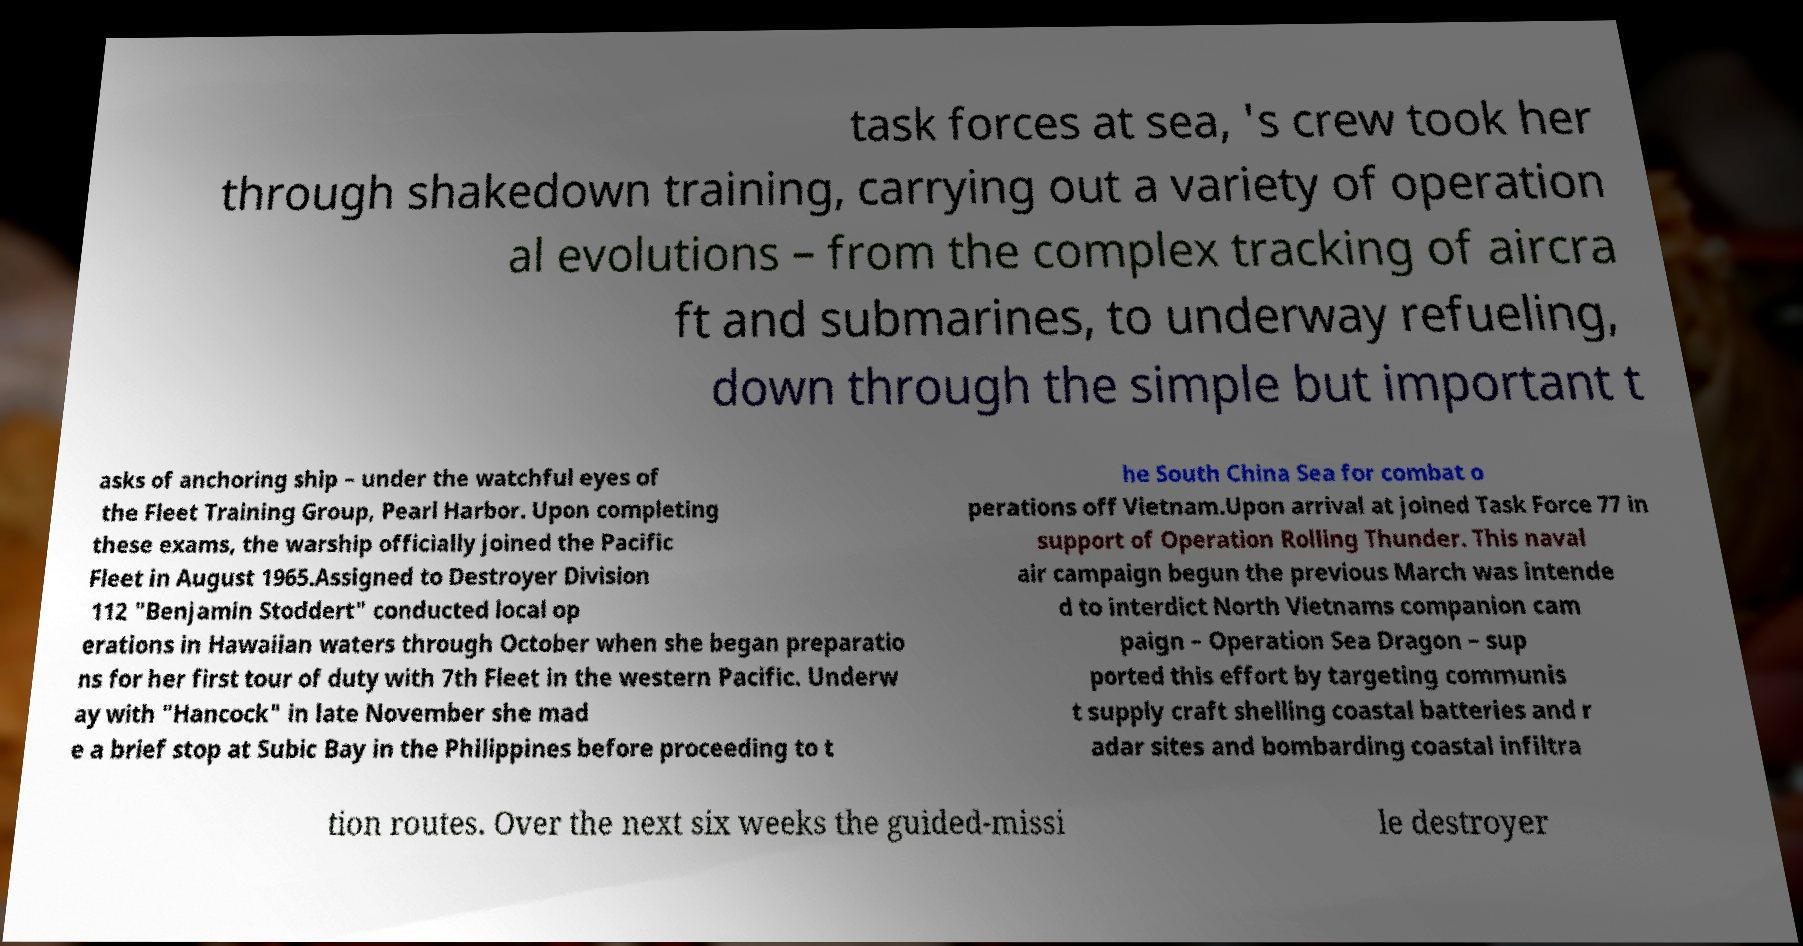Please read and relay the text visible in this image. What does it say? task forces at sea, 's crew took her through shakedown training, carrying out a variety of operation al evolutions – from the complex tracking of aircra ft and submarines, to underway refueling, down through the simple but important t asks of anchoring ship – under the watchful eyes of the Fleet Training Group, Pearl Harbor. Upon completing these exams, the warship officially joined the Pacific Fleet in August 1965.Assigned to Destroyer Division 112 "Benjamin Stoddert" conducted local op erations in Hawaiian waters through October when she began preparatio ns for her first tour of duty with 7th Fleet in the western Pacific. Underw ay with "Hancock" in late November she mad e a brief stop at Subic Bay in the Philippines before proceeding to t he South China Sea for combat o perations off Vietnam.Upon arrival at joined Task Force 77 in support of Operation Rolling Thunder. This naval air campaign begun the previous March was intende d to interdict North Vietnams companion cam paign – Operation Sea Dragon – sup ported this effort by targeting communis t supply craft shelling coastal batteries and r adar sites and bombarding coastal infiltra tion routes. Over the next six weeks the guided-missi le destroyer 